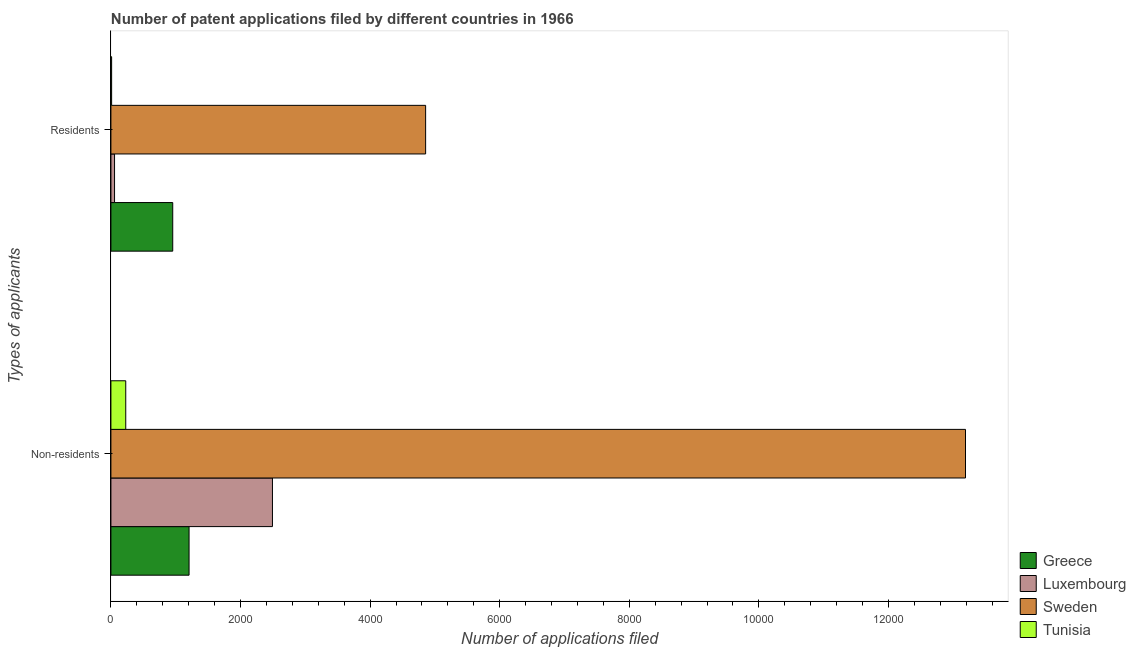How many different coloured bars are there?
Offer a very short reply. 4. How many groups of bars are there?
Provide a succinct answer. 2. Are the number of bars on each tick of the Y-axis equal?
Keep it short and to the point. Yes. How many bars are there on the 1st tick from the top?
Provide a short and direct response. 4. How many bars are there on the 2nd tick from the bottom?
Your answer should be compact. 4. What is the label of the 1st group of bars from the top?
Your answer should be very brief. Residents. What is the number of patent applications by non residents in Luxembourg?
Provide a succinct answer. 2493. Across all countries, what is the maximum number of patent applications by non residents?
Keep it short and to the point. 1.32e+04. Across all countries, what is the minimum number of patent applications by residents?
Give a very brief answer. 11. In which country was the number of patent applications by residents minimum?
Provide a succinct answer. Tunisia. What is the total number of patent applications by non residents in the graph?
Your answer should be compact. 1.71e+04. What is the difference between the number of patent applications by non residents in Luxembourg and that in Tunisia?
Ensure brevity in your answer.  2264. What is the difference between the number of patent applications by non residents in Tunisia and the number of patent applications by residents in Sweden?
Ensure brevity in your answer.  -4628. What is the average number of patent applications by residents per country?
Offer a terse response. 1469.5. What is the difference between the number of patent applications by non residents and number of patent applications by residents in Luxembourg?
Offer a very short reply. 2437. In how many countries, is the number of patent applications by residents greater than 11200 ?
Make the answer very short. 0. What is the ratio of the number of patent applications by non residents in Luxembourg to that in Sweden?
Offer a very short reply. 0.19. What does the 2nd bar from the bottom in Residents represents?
Keep it short and to the point. Luxembourg. Are all the bars in the graph horizontal?
Your response must be concise. Yes. How many countries are there in the graph?
Your answer should be compact. 4. What is the difference between two consecutive major ticks on the X-axis?
Offer a terse response. 2000. Are the values on the major ticks of X-axis written in scientific E-notation?
Provide a short and direct response. No. Does the graph contain any zero values?
Offer a terse response. No. How many legend labels are there?
Offer a very short reply. 4. How are the legend labels stacked?
Keep it short and to the point. Vertical. What is the title of the graph?
Give a very brief answer. Number of patent applications filed by different countries in 1966. Does "Iran" appear as one of the legend labels in the graph?
Keep it short and to the point. No. What is the label or title of the X-axis?
Offer a terse response. Number of applications filed. What is the label or title of the Y-axis?
Your answer should be very brief. Types of applicants. What is the Number of applications filed in Greece in Non-residents?
Offer a terse response. 1206. What is the Number of applications filed of Luxembourg in Non-residents?
Keep it short and to the point. 2493. What is the Number of applications filed of Sweden in Non-residents?
Your answer should be compact. 1.32e+04. What is the Number of applications filed in Tunisia in Non-residents?
Your answer should be compact. 229. What is the Number of applications filed of Greece in Residents?
Your answer should be very brief. 954. What is the Number of applications filed in Sweden in Residents?
Ensure brevity in your answer.  4857. What is the Number of applications filed of Tunisia in Residents?
Your response must be concise. 11. Across all Types of applicants, what is the maximum Number of applications filed of Greece?
Your answer should be very brief. 1206. Across all Types of applicants, what is the maximum Number of applications filed of Luxembourg?
Your answer should be very brief. 2493. Across all Types of applicants, what is the maximum Number of applications filed in Sweden?
Your answer should be compact. 1.32e+04. Across all Types of applicants, what is the maximum Number of applications filed in Tunisia?
Keep it short and to the point. 229. Across all Types of applicants, what is the minimum Number of applications filed of Greece?
Provide a short and direct response. 954. Across all Types of applicants, what is the minimum Number of applications filed in Luxembourg?
Keep it short and to the point. 56. Across all Types of applicants, what is the minimum Number of applications filed in Sweden?
Provide a short and direct response. 4857. Across all Types of applicants, what is the minimum Number of applications filed in Tunisia?
Your answer should be compact. 11. What is the total Number of applications filed in Greece in the graph?
Provide a short and direct response. 2160. What is the total Number of applications filed of Luxembourg in the graph?
Provide a short and direct response. 2549. What is the total Number of applications filed in Sweden in the graph?
Offer a terse response. 1.80e+04. What is the total Number of applications filed of Tunisia in the graph?
Your response must be concise. 240. What is the difference between the Number of applications filed in Greece in Non-residents and that in Residents?
Provide a succinct answer. 252. What is the difference between the Number of applications filed of Luxembourg in Non-residents and that in Residents?
Give a very brief answer. 2437. What is the difference between the Number of applications filed in Sweden in Non-residents and that in Residents?
Offer a very short reply. 8332. What is the difference between the Number of applications filed of Tunisia in Non-residents and that in Residents?
Offer a terse response. 218. What is the difference between the Number of applications filed of Greece in Non-residents and the Number of applications filed of Luxembourg in Residents?
Offer a very short reply. 1150. What is the difference between the Number of applications filed in Greece in Non-residents and the Number of applications filed in Sweden in Residents?
Your answer should be very brief. -3651. What is the difference between the Number of applications filed of Greece in Non-residents and the Number of applications filed of Tunisia in Residents?
Your response must be concise. 1195. What is the difference between the Number of applications filed of Luxembourg in Non-residents and the Number of applications filed of Sweden in Residents?
Provide a succinct answer. -2364. What is the difference between the Number of applications filed in Luxembourg in Non-residents and the Number of applications filed in Tunisia in Residents?
Offer a terse response. 2482. What is the difference between the Number of applications filed in Sweden in Non-residents and the Number of applications filed in Tunisia in Residents?
Provide a succinct answer. 1.32e+04. What is the average Number of applications filed in Greece per Types of applicants?
Ensure brevity in your answer.  1080. What is the average Number of applications filed in Luxembourg per Types of applicants?
Offer a very short reply. 1274.5. What is the average Number of applications filed of Sweden per Types of applicants?
Make the answer very short. 9023. What is the average Number of applications filed of Tunisia per Types of applicants?
Offer a terse response. 120. What is the difference between the Number of applications filed in Greece and Number of applications filed in Luxembourg in Non-residents?
Keep it short and to the point. -1287. What is the difference between the Number of applications filed in Greece and Number of applications filed in Sweden in Non-residents?
Provide a succinct answer. -1.20e+04. What is the difference between the Number of applications filed in Greece and Number of applications filed in Tunisia in Non-residents?
Offer a terse response. 977. What is the difference between the Number of applications filed in Luxembourg and Number of applications filed in Sweden in Non-residents?
Keep it short and to the point. -1.07e+04. What is the difference between the Number of applications filed in Luxembourg and Number of applications filed in Tunisia in Non-residents?
Offer a very short reply. 2264. What is the difference between the Number of applications filed in Sweden and Number of applications filed in Tunisia in Non-residents?
Offer a very short reply. 1.30e+04. What is the difference between the Number of applications filed of Greece and Number of applications filed of Luxembourg in Residents?
Provide a short and direct response. 898. What is the difference between the Number of applications filed in Greece and Number of applications filed in Sweden in Residents?
Provide a succinct answer. -3903. What is the difference between the Number of applications filed of Greece and Number of applications filed of Tunisia in Residents?
Keep it short and to the point. 943. What is the difference between the Number of applications filed in Luxembourg and Number of applications filed in Sweden in Residents?
Your response must be concise. -4801. What is the difference between the Number of applications filed of Luxembourg and Number of applications filed of Tunisia in Residents?
Provide a short and direct response. 45. What is the difference between the Number of applications filed of Sweden and Number of applications filed of Tunisia in Residents?
Offer a very short reply. 4846. What is the ratio of the Number of applications filed of Greece in Non-residents to that in Residents?
Provide a short and direct response. 1.26. What is the ratio of the Number of applications filed in Luxembourg in Non-residents to that in Residents?
Provide a succinct answer. 44.52. What is the ratio of the Number of applications filed of Sweden in Non-residents to that in Residents?
Provide a short and direct response. 2.72. What is the ratio of the Number of applications filed of Tunisia in Non-residents to that in Residents?
Ensure brevity in your answer.  20.82. What is the difference between the highest and the second highest Number of applications filed of Greece?
Your answer should be compact. 252. What is the difference between the highest and the second highest Number of applications filed in Luxembourg?
Make the answer very short. 2437. What is the difference between the highest and the second highest Number of applications filed in Sweden?
Give a very brief answer. 8332. What is the difference between the highest and the second highest Number of applications filed of Tunisia?
Your answer should be very brief. 218. What is the difference between the highest and the lowest Number of applications filed of Greece?
Your answer should be compact. 252. What is the difference between the highest and the lowest Number of applications filed of Luxembourg?
Provide a succinct answer. 2437. What is the difference between the highest and the lowest Number of applications filed in Sweden?
Keep it short and to the point. 8332. What is the difference between the highest and the lowest Number of applications filed of Tunisia?
Offer a very short reply. 218. 